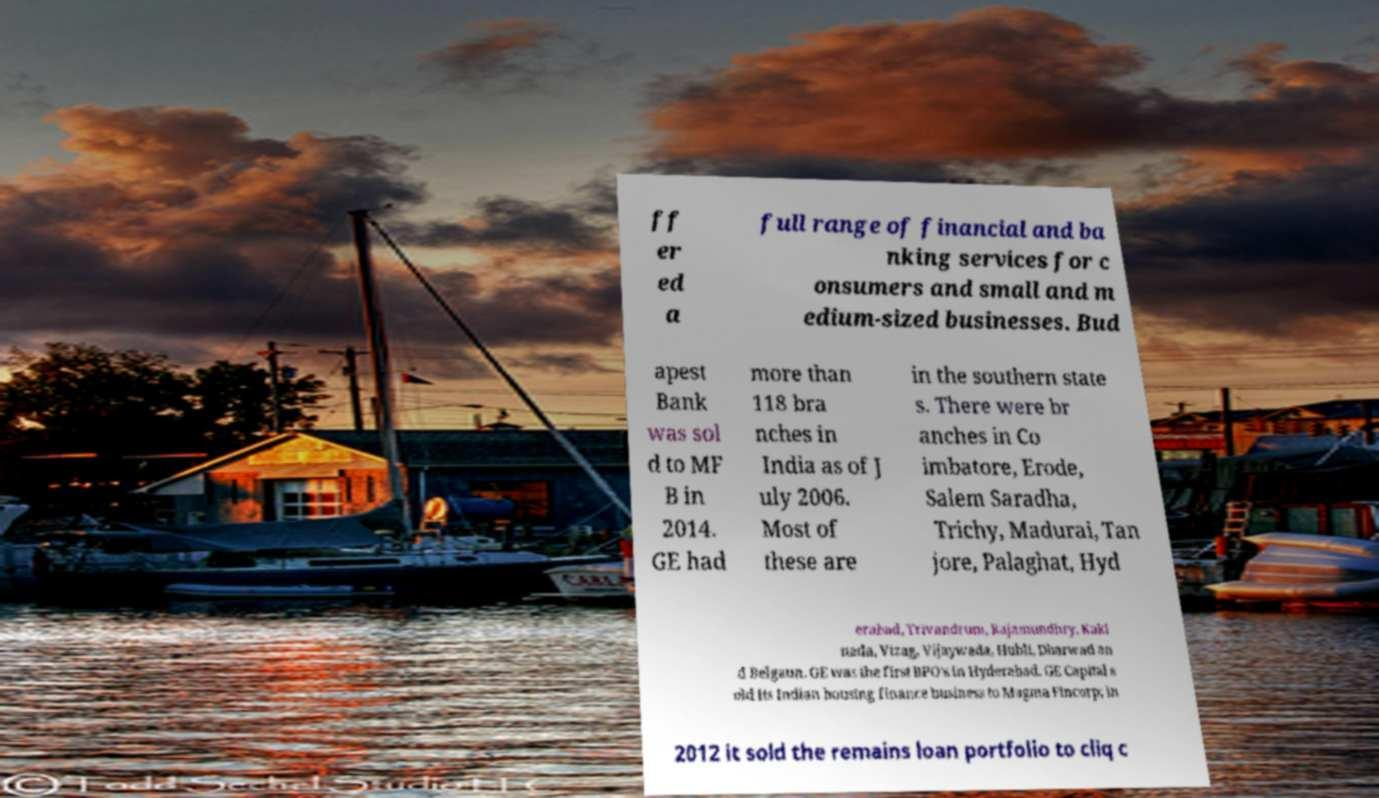Please identify and transcribe the text found in this image. ff er ed a full range of financial and ba nking services for c onsumers and small and m edium-sized businesses. Bud apest Bank was sol d to MF B in 2014. GE had more than 118 bra nches in India as of J uly 2006. Most of these are in the southern state s. There were br anches in Co imbatore, Erode, Salem Saradha, Trichy, Madurai, Tan jore, Palaghat, Hyd erabad, Trivandrum, Rajamundhry, Kaki nada, Vizag, Vijaywada, Hubli, Dharwad an d Belgaun. GE was the first BPO's in Hyderabad. GE Capital s old its Indian housing finance business to Magma Fincorp; in 2012 it sold the remains loan portfolio to cliq c 